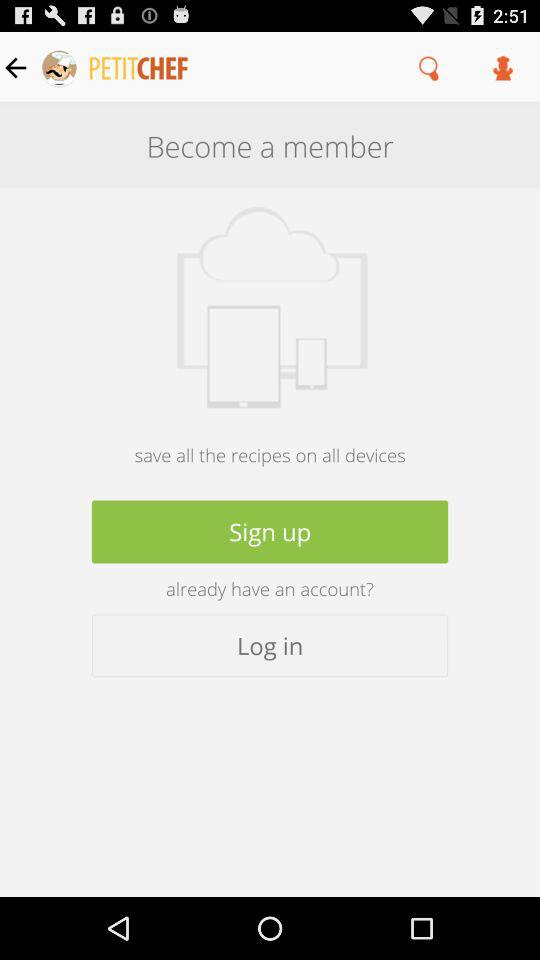What is the app name? The app name is "PETITCHEF". 